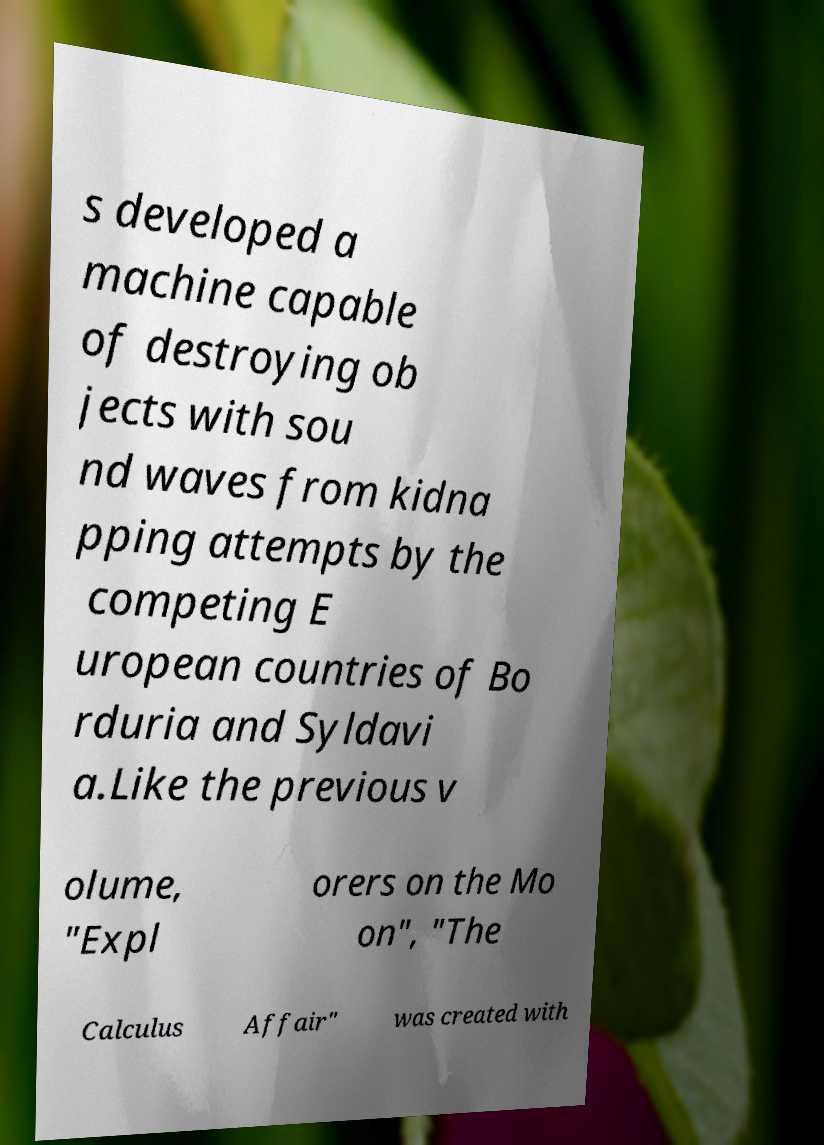I need the written content from this picture converted into text. Can you do that? s developed a machine capable of destroying ob jects with sou nd waves from kidna pping attempts by the competing E uropean countries of Bo rduria and Syldavi a.Like the previous v olume, "Expl orers on the Mo on", "The Calculus Affair" was created with 